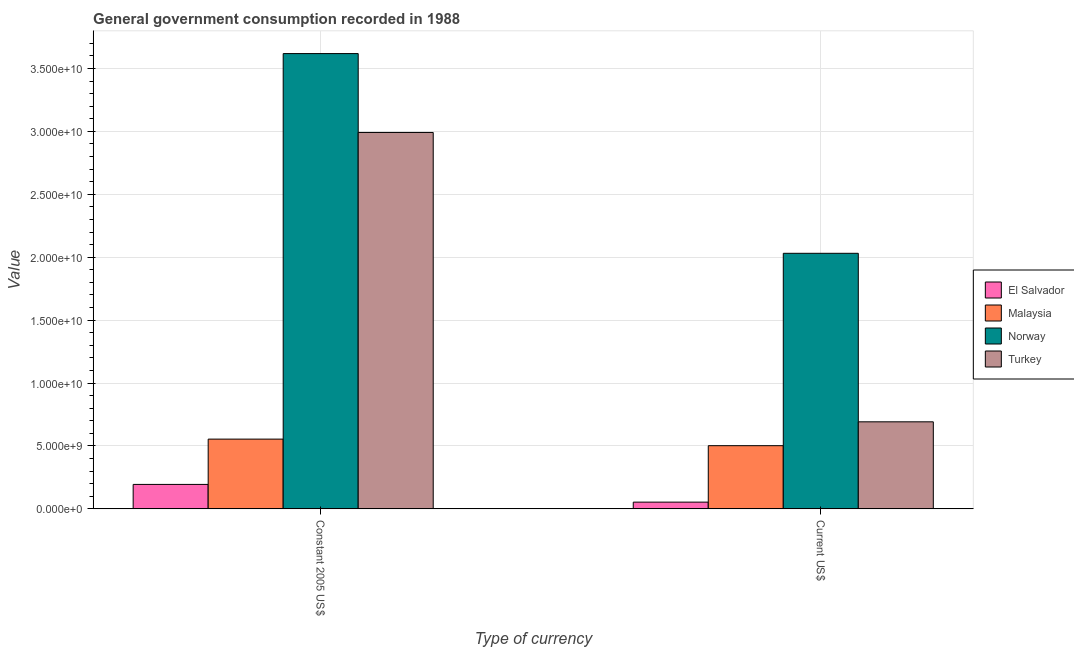How many different coloured bars are there?
Your answer should be compact. 4. Are the number of bars per tick equal to the number of legend labels?
Keep it short and to the point. Yes. Are the number of bars on each tick of the X-axis equal?
Give a very brief answer. Yes. How many bars are there on the 2nd tick from the right?
Your answer should be very brief. 4. What is the label of the 2nd group of bars from the left?
Your answer should be compact. Current US$. What is the value consumed in current us$ in Norway?
Your answer should be compact. 2.03e+1. Across all countries, what is the maximum value consumed in current us$?
Your response must be concise. 2.03e+1. Across all countries, what is the minimum value consumed in current us$?
Your answer should be very brief. 5.33e+08. In which country was the value consumed in constant 2005 us$ minimum?
Your answer should be compact. El Salvador. What is the total value consumed in constant 2005 us$ in the graph?
Your response must be concise. 7.36e+1. What is the difference between the value consumed in current us$ in Turkey and that in El Salvador?
Make the answer very short. 6.38e+09. What is the difference between the value consumed in constant 2005 us$ in Norway and the value consumed in current us$ in Malaysia?
Make the answer very short. 3.12e+1. What is the average value consumed in constant 2005 us$ per country?
Your response must be concise. 1.84e+1. What is the difference between the value consumed in current us$ and value consumed in constant 2005 us$ in Norway?
Give a very brief answer. -1.59e+1. What is the ratio of the value consumed in current us$ in El Salvador to that in Turkey?
Offer a terse response. 0.08. Is the value consumed in constant 2005 us$ in Malaysia less than that in Turkey?
Your answer should be compact. Yes. In how many countries, is the value consumed in current us$ greater than the average value consumed in current us$ taken over all countries?
Offer a terse response. 1. What does the 1st bar from the left in Constant 2005 US$ represents?
Your answer should be compact. El Salvador. What does the 4th bar from the right in Constant 2005 US$ represents?
Provide a succinct answer. El Salvador. How many bars are there?
Your answer should be very brief. 8. Are all the bars in the graph horizontal?
Ensure brevity in your answer.  No. Are the values on the major ticks of Y-axis written in scientific E-notation?
Offer a terse response. Yes. What is the title of the graph?
Provide a short and direct response. General government consumption recorded in 1988. Does "South Africa" appear as one of the legend labels in the graph?
Provide a succinct answer. No. What is the label or title of the X-axis?
Provide a succinct answer. Type of currency. What is the label or title of the Y-axis?
Your answer should be compact. Value. What is the Value in El Salvador in Constant 2005 US$?
Your answer should be very brief. 1.94e+09. What is the Value of Malaysia in Constant 2005 US$?
Your answer should be compact. 5.54e+09. What is the Value in Norway in Constant 2005 US$?
Keep it short and to the point. 3.62e+1. What is the Value of Turkey in Constant 2005 US$?
Keep it short and to the point. 2.99e+1. What is the Value of El Salvador in Current US$?
Your answer should be very brief. 5.33e+08. What is the Value in Malaysia in Current US$?
Your response must be concise. 5.02e+09. What is the Value in Norway in Current US$?
Give a very brief answer. 2.03e+1. What is the Value in Turkey in Current US$?
Offer a terse response. 6.92e+09. Across all Type of currency, what is the maximum Value in El Salvador?
Offer a very short reply. 1.94e+09. Across all Type of currency, what is the maximum Value of Malaysia?
Your response must be concise. 5.54e+09. Across all Type of currency, what is the maximum Value in Norway?
Offer a terse response. 3.62e+1. Across all Type of currency, what is the maximum Value of Turkey?
Provide a short and direct response. 2.99e+1. Across all Type of currency, what is the minimum Value of El Salvador?
Keep it short and to the point. 5.33e+08. Across all Type of currency, what is the minimum Value of Malaysia?
Provide a short and direct response. 5.02e+09. Across all Type of currency, what is the minimum Value in Norway?
Keep it short and to the point. 2.03e+1. Across all Type of currency, what is the minimum Value of Turkey?
Ensure brevity in your answer.  6.92e+09. What is the total Value of El Salvador in the graph?
Offer a terse response. 2.48e+09. What is the total Value in Malaysia in the graph?
Give a very brief answer. 1.06e+1. What is the total Value of Norway in the graph?
Keep it short and to the point. 5.65e+1. What is the total Value in Turkey in the graph?
Make the answer very short. 3.68e+1. What is the difference between the Value of El Salvador in Constant 2005 US$ and that in Current US$?
Offer a terse response. 1.41e+09. What is the difference between the Value in Malaysia in Constant 2005 US$ and that in Current US$?
Ensure brevity in your answer.  5.22e+08. What is the difference between the Value of Norway in Constant 2005 US$ and that in Current US$?
Your answer should be very brief. 1.59e+1. What is the difference between the Value of Turkey in Constant 2005 US$ and that in Current US$?
Keep it short and to the point. 2.30e+1. What is the difference between the Value of El Salvador in Constant 2005 US$ and the Value of Malaysia in Current US$?
Provide a succinct answer. -3.08e+09. What is the difference between the Value of El Salvador in Constant 2005 US$ and the Value of Norway in Current US$?
Your answer should be compact. -1.84e+1. What is the difference between the Value in El Salvador in Constant 2005 US$ and the Value in Turkey in Current US$?
Make the answer very short. -4.97e+09. What is the difference between the Value in Malaysia in Constant 2005 US$ and the Value in Norway in Current US$?
Give a very brief answer. -1.48e+1. What is the difference between the Value of Malaysia in Constant 2005 US$ and the Value of Turkey in Current US$?
Provide a short and direct response. -1.37e+09. What is the difference between the Value in Norway in Constant 2005 US$ and the Value in Turkey in Current US$?
Ensure brevity in your answer.  2.93e+1. What is the average Value of El Salvador per Type of currency?
Offer a very short reply. 1.24e+09. What is the average Value of Malaysia per Type of currency?
Offer a terse response. 5.28e+09. What is the average Value of Norway per Type of currency?
Keep it short and to the point. 2.82e+1. What is the average Value of Turkey per Type of currency?
Your answer should be compact. 1.84e+1. What is the difference between the Value in El Salvador and Value in Malaysia in Constant 2005 US$?
Your response must be concise. -3.60e+09. What is the difference between the Value in El Salvador and Value in Norway in Constant 2005 US$?
Your response must be concise. -3.42e+1. What is the difference between the Value of El Salvador and Value of Turkey in Constant 2005 US$?
Offer a very short reply. -2.80e+1. What is the difference between the Value of Malaysia and Value of Norway in Constant 2005 US$?
Make the answer very short. -3.06e+1. What is the difference between the Value in Malaysia and Value in Turkey in Constant 2005 US$?
Keep it short and to the point. -2.44e+1. What is the difference between the Value of Norway and Value of Turkey in Constant 2005 US$?
Offer a very short reply. 6.27e+09. What is the difference between the Value of El Salvador and Value of Malaysia in Current US$?
Make the answer very short. -4.49e+09. What is the difference between the Value of El Salvador and Value of Norway in Current US$?
Provide a short and direct response. -1.98e+1. What is the difference between the Value in El Salvador and Value in Turkey in Current US$?
Provide a succinct answer. -6.38e+09. What is the difference between the Value of Malaysia and Value of Norway in Current US$?
Make the answer very short. -1.53e+1. What is the difference between the Value of Malaysia and Value of Turkey in Current US$?
Give a very brief answer. -1.90e+09. What is the difference between the Value of Norway and Value of Turkey in Current US$?
Keep it short and to the point. 1.34e+1. What is the ratio of the Value of El Salvador in Constant 2005 US$ to that in Current US$?
Your answer should be very brief. 3.64. What is the ratio of the Value of Malaysia in Constant 2005 US$ to that in Current US$?
Offer a very short reply. 1.1. What is the ratio of the Value in Norway in Constant 2005 US$ to that in Current US$?
Your response must be concise. 1.78. What is the ratio of the Value of Turkey in Constant 2005 US$ to that in Current US$?
Give a very brief answer. 4.33. What is the difference between the highest and the second highest Value of El Salvador?
Your answer should be very brief. 1.41e+09. What is the difference between the highest and the second highest Value in Malaysia?
Provide a succinct answer. 5.22e+08. What is the difference between the highest and the second highest Value in Norway?
Provide a succinct answer. 1.59e+1. What is the difference between the highest and the second highest Value of Turkey?
Keep it short and to the point. 2.30e+1. What is the difference between the highest and the lowest Value in El Salvador?
Provide a succinct answer. 1.41e+09. What is the difference between the highest and the lowest Value in Malaysia?
Ensure brevity in your answer.  5.22e+08. What is the difference between the highest and the lowest Value in Norway?
Your answer should be compact. 1.59e+1. What is the difference between the highest and the lowest Value of Turkey?
Your answer should be very brief. 2.30e+1. 